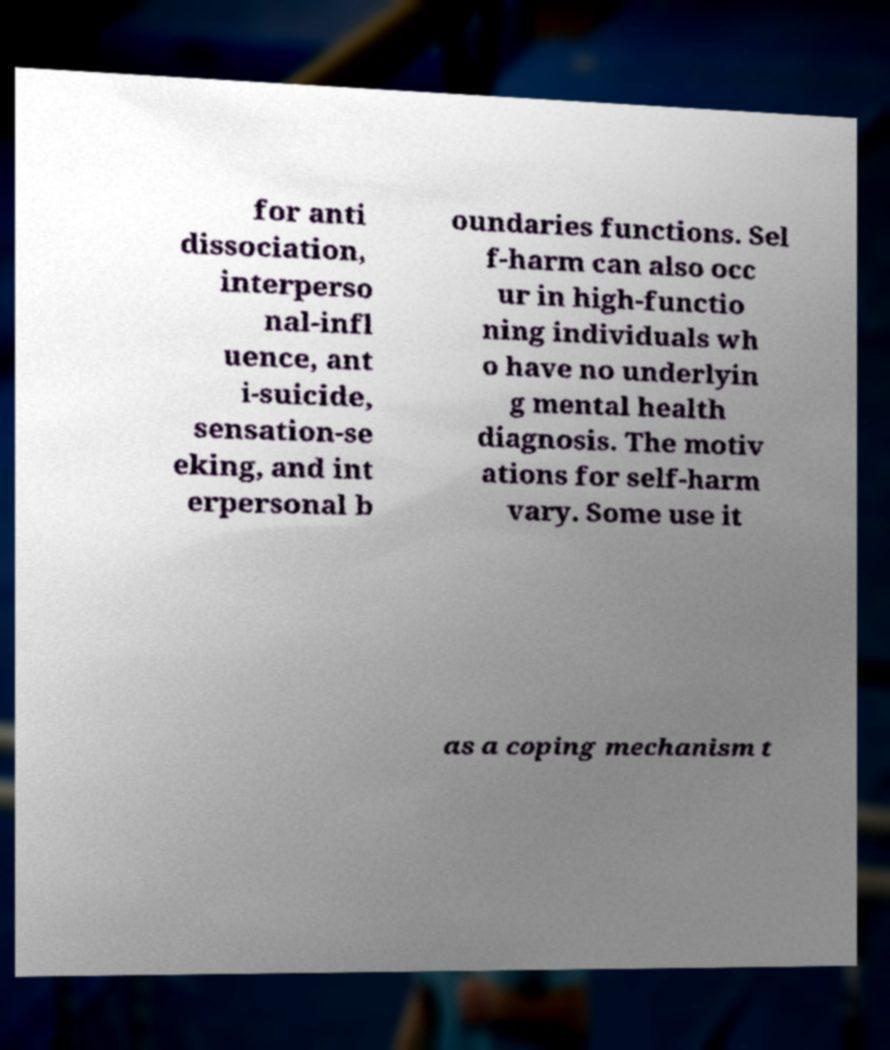I need the written content from this picture converted into text. Can you do that? for anti dissociation, interperso nal-infl uence, ant i-suicide, sensation-se eking, and int erpersonal b oundaries functions. Sel f-harm can also occ ur in high-functio ning individuals wh o have no underlyin g mental health diagnosis. The motiv ations for self-harm vary. Some use it as a coping mechanism t 